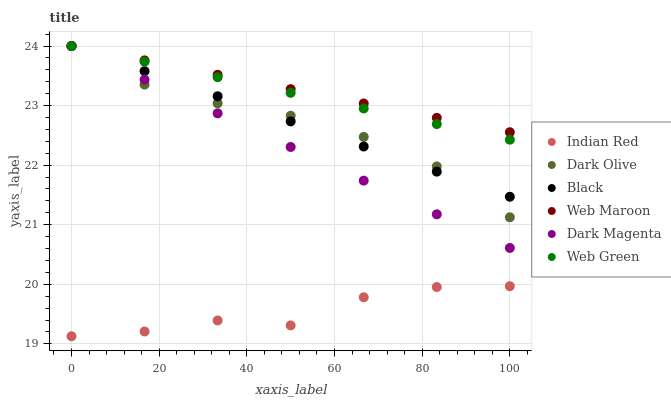Does Indian Red have the minimum area under the curve?
Answer yes or no. Yes. Does Web Maroon have the maximum area under the curve?
Answer yes or no. Yes. Does Dark Olive have the minimum area under the curve?
Answer yes or no. No. Does Dark Olive have the maximum area under the curve?
Answer yes or no. No. Is Web Green the smoothest?
Answer yes or no. Yes. Is Indian Red the roughest?
Answer yes or no. Yes. Is Dark Olive the smoothest?
Answer yes or no. No. Is Dark Olive the roughest?
Answer yes or no. No. Does Indian Red have the lowest value?
Answer yes or no. Yes. Does Dark Olive have the lowest value?
Answer yes or no. No. Does Black have the highest value?
Answer yes or no. Yes. Does Indian Red have the highest value?
Answer yes or no. No. Is Indian Red less than Dark Magenta?
Answer yes or no. Yes. Is Dark Olive greater than Indian Red?
Answer yes or no. Yes. Does Dark Magenta intersect Black?
Answer yes or no. Yes. Is Dark Magenta less than Black?
Answer yes or no. No. Is Dark Magenta greater than Black?
Answer yes or no. No. Does Indian Red intersect Dark Magenta?
Answer yes or no. No. 